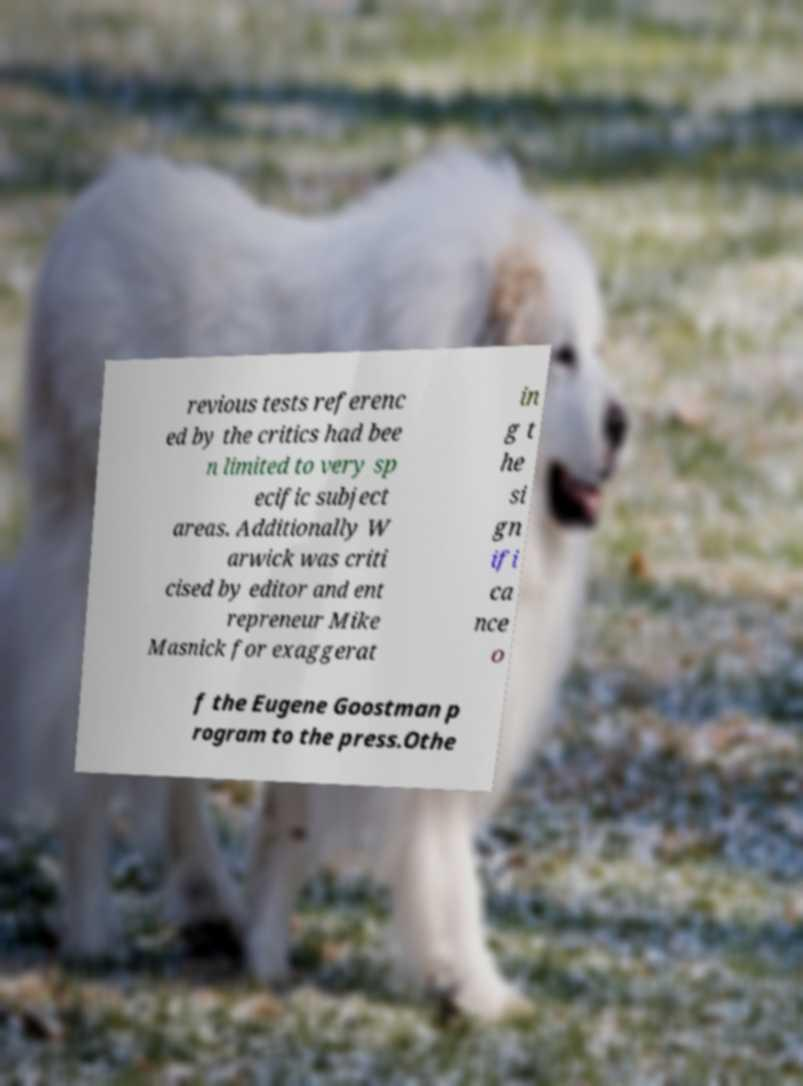Can you accurately transcribe the text from the provided image for me? revious tests referenc ed by the critics had bee n limited to very sp ecific subject areas. Additionally W arwick was criti cised by editor and ent repreneur Mike Masnick for exaggerat in g t he si gn ifi ca nce o f the Eugene Goostman p rogram to the press.Othe 